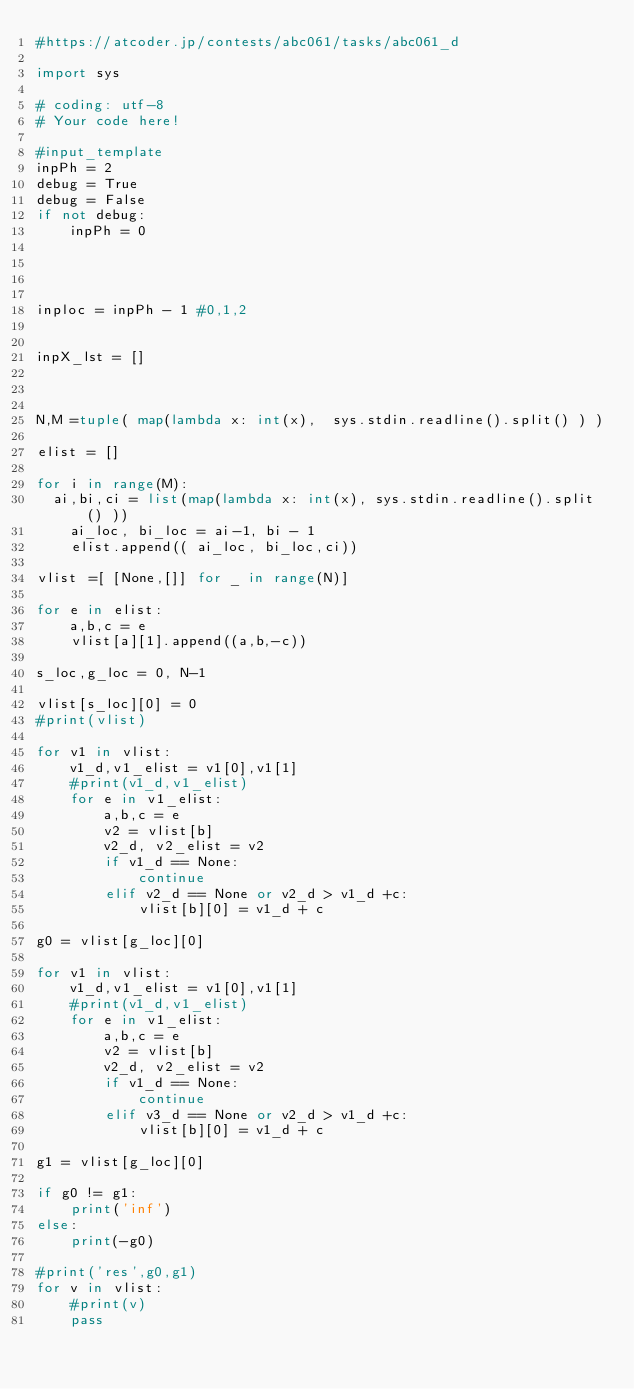Convert code to text. <code><loc_0><loc_0><loc_500><loc_500><_Python_>#https://atcoder.jp/contests/abc061/tasks/abc061_d

import sys

# coding: utf-8
# Your code here!

#input_template
inpPh = 2
debug = True
debug = False
if not debug:
    inpPh = 0



    
inploc = inpPh - 1 #0,1,2


inpX_lst = []



N,M =tuple( map(lambda x: int(x),  sys.stdin.readline().split() ) )

elist = []    

for i in range(M):
	ai,bi,ci = list(map(lambda x: int(x), sys.stdin.readline().split() ))
    ai_loc, bi_loc = ai-1, bi - 1
    elist.append(( ai_loc, bi_loc,ci))

vlist =[ [None,[]] for _ in range(N)]    

for e in elist:
    a,b,c = e
    vlist[a][1].append((a,b,-c))
        
s_loc,g_loc = 0, N-1

vlist[s_loc][0] = 0
#print(vlist)

for v1 in vlist:
    v1_d,v1_elist = v1[0],v1[1]
    #print(v1_d,v1_elist)
    for e in v1_elist:
        a,b,c = e
        v2 = vlist[b]
        v2_d, v2_elist = v2
        if v1_d == None:
            continue
        elif v2_d == None or v2_d > v1_d +c:
            vlist[b][0] = v1_d + c

g0 = vlist[g_loc][0]            

for v1 in vlist:
    v1_d,v1_elist = v1[0],v1[1]
    #print(v1_d,v1_elist)
    for e in v1_elist:
        a,b,c = e
        v2 = vlist[b]
        v2_d, v2_elist = v2
        if v1_d == None:
            continue
        elif v3_d == None or v2_d > v1_d +c:
            vlist[b][0] = v1_d + c

g1 = vlist[g_loc][0]  

if g0 != g1:
    print('inf')
else:
    print(-g0)

#print('res',g0,g1)
for v in vlist:
    #print(v)        
    pass

</code> 